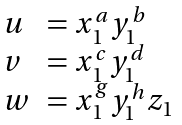Convert formula to latex. <formula><loc_0><loc_0><loc_500><loc_500>\begin{array} { l l } u & = x _ { 1 } ^ { a } y _ { 1 } ^ { b } \\ v & = x _ { 1 } ^ { c } y _ { 1 } ^ { d } \\ w & = x _ { 1 } ^ { g } y _ { 1 } ^ { h } z _ { 1 } \end{array}</formula> 